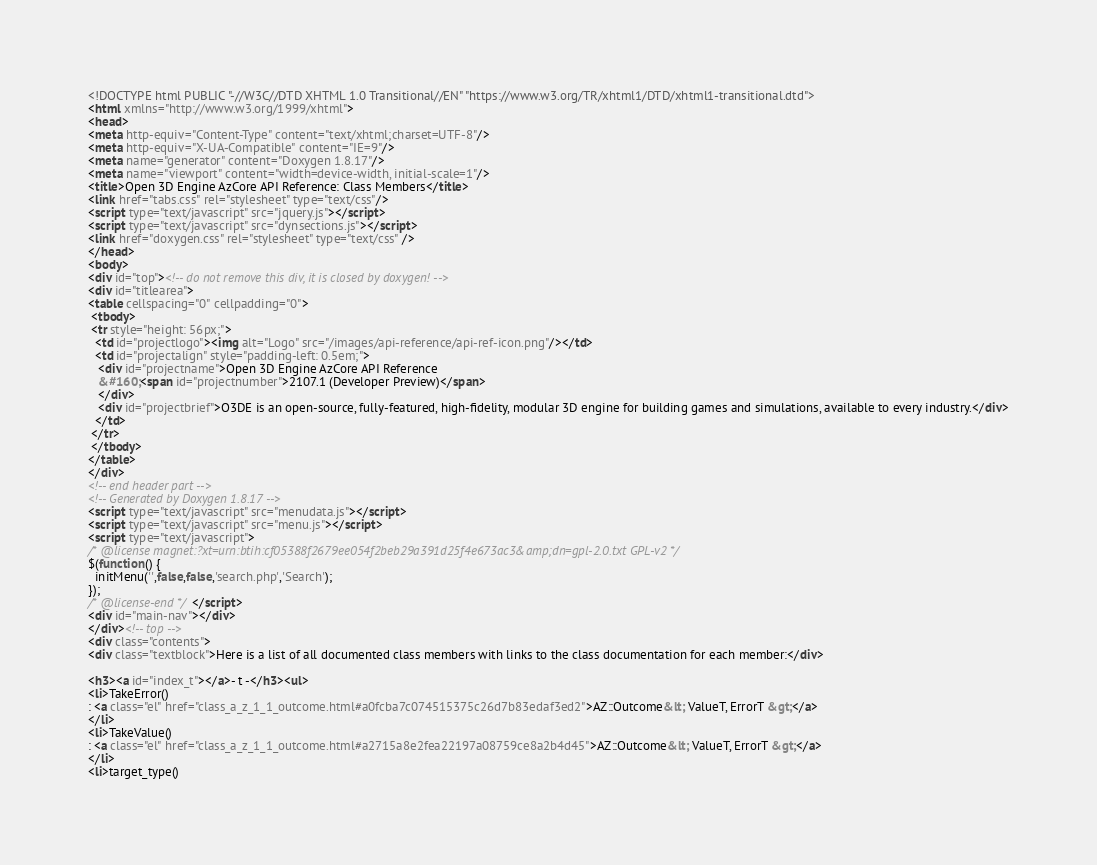<code> <loc_0><loc_0><loc_500><loc_500><_HTML_><!DOCTYPE html PUBLIC "-//W3C//DTD XHTML 1.0 Transitional//EN" "https://www.w3.org/TR/xhtml1/DTD/xhtml1-transitional.dtd">
<html xmlns="http://www.w3.org/1999/xhtml">
<head>
<meta http-equiv="Content-Type" content="text/xhtml;charset=UTF-8"/>
<meta http-equiv="X-UA-Compatible" content="IE=9"/>
<meta name="generator" content="Doxygen 1.8.17"/>
<meta name="viewport" content="width=device-width, initial-scale=1"/>
<title>Open 3D Engine AzCore API Reference: Class Members</title>
<link href="tabs.css" rel="stylesheet" type="text/css"/>
<script type="text/javascript" src="jquery.js"></script>
<script type="text/javascript" src="dynsections.js"></script>
<link href="doxygen.css" rel="stylesheet" type="text/css" />
</head>
<body>
<div id="top"><!-- do not remove this div, it is closed by doxygen! -->
<div id="titlearea">
<table cellspacing="0" cellpadding="0">
 <tbody>
 <tr style="height: 56px;">
  <td id="projectlogo"><img alt="Logo" src="/images/api-reference/api-ref-icon.png"/></td>
  <td id="projectalign" style="padding-left: 0.5em;">
   <div id="projectname">Open 3D Engine AzCore API Reference
   &#160;<span id="projectnumber">2107.1 (Developer Preview)</span>
   </div>
   <div id="projectbrief">O3DE is an open-source, fully-featured, high-fidelity, modular 3D engine for building games and simulations, available to every industry.</div>
  </td>
 </tr>
 </tbody>
</table>
</div>
<!-- end header part -->
<!-- Generated by Doxygen 1.8.17 -->
<script type="text/javascript" src="menudata.js"></script>
<script type="text/javascript" src="menu.js"></script>
<script type="text/javascript">
/* @license magnet:?xt=urn:btih:cf05388f2679ee054f2beb29a391d25f4e673ac3&amp;dn=gpl-2.0.txt GPL-v2 */
$(function() {
  initMenu('',false,false,'search.php','Search');
});
/* @license-end */</script>
<div id="main-nav"></div>
</div><!-- top -->
<div class="contents">
<div class="textblock">Here is a list of all documented class members with links to the class documentation for each member:</div>

<h3><a id="index_t"></a>- t -</h3><ul>
<li>TakeError()
: <a class="el" href="class_a_z_1_1_outcome.html#a0fcba7c074515375c26d7b83edaf3ed2">AZ::Outcome&lt; ValueT, ErrorT &gt;</a>
</li>
<li>TakeValue()
: <a class="el" href="class_a_z_1_1_outcome.html#a2715a8e2fea22197a08759ce8a2b4d45">AZ::Outcome&lt; ValueT, ErrorT &gt;</a>
</li>
<li>target_type()</code> 